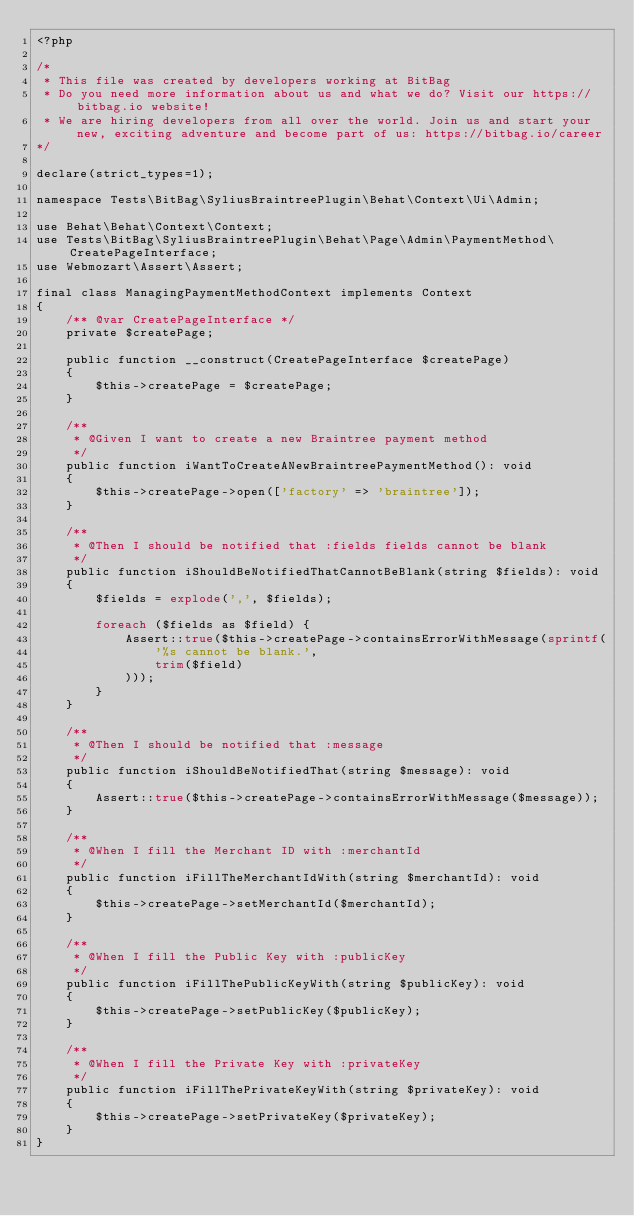Convert code to text. <code><loc_0><loc_0><loc_500><loc_500><_PHP_><?php

/*
 * This file was created by developers working at BitBag
 * Do you need more information about us and what we do? Visit our https://bitbag.io website!
 * We are hiring developers from all over the world. Join us and start your new, exciting adventure and become part of us: https://bitbag.io/career
*/

declare(strict_types=1);

namespace Tests\BitBag\SyliusBraintreePlugin\Behat\Context\Ui\Admin;

use Behat\Behat\Context\Context;
use Tests\BitBag\SyliusBraintreePlugin\Behat\Page\Admin\PaymentMethod\CreatePageInterface;
use Webmozart\Assert\Assert;

final class ManagingPaymentMethodContext implements Context
{
    /** @var CreatePageInterface */
    private $createPage;

    public function __construct(CreatePageInterface $createPage)
    {
        $this->createPage = $createPage;
    }

    /**
     * @Given I want to create a new Braintree payment method
     */
    public function iWantToCreateANewBraintreePaymentMethod(): void
    {
        $this->createPage->open(['factory' => 'braintree']);
    }

    /**
     * @Then I should be notified that :fields fields cannot be blank
     */
    public function iShouldBeNotifiedThatCannotBeBlank(string $fields): void
    {
        $fields = explode(',', $fields);

        foreach ($fields as $field) {
            Assert::true($this->createPage->containsErrorWithMessage(sprintf(
                '%s cannot be blank.',
                trim($field)
            )));
        }
    }

    /**
     * @Then I should be notified that :message
     */
    public function iShouldBeNotifiedThat(string $message): void
    {
        Assert::true($this->createPage->containsErrorWithMessage($message));
    }

    /**
     * @When I fill the Merchant ID with :merchantId
     */
    public function iFillTheMerchantIdWith(string $merchantId): void
    {
        $this->createPage->setMerchantId($merchantId);
    }

    /**
     * @When I fill the Public Key with :publicKey
     */
    public function iFillThePublicKeyWith(string $publicKey): void
    {
        $this->createPage->setPublicKey($publicKey);
    }

    /**
     * @When I fill the Private Key with :privateKey
     */
    public function iFillThePrivateKeyWith(string $privateKey): void
    {
        $this->createPage->setPrivateKey($privateKey);
    }
}
</code> 